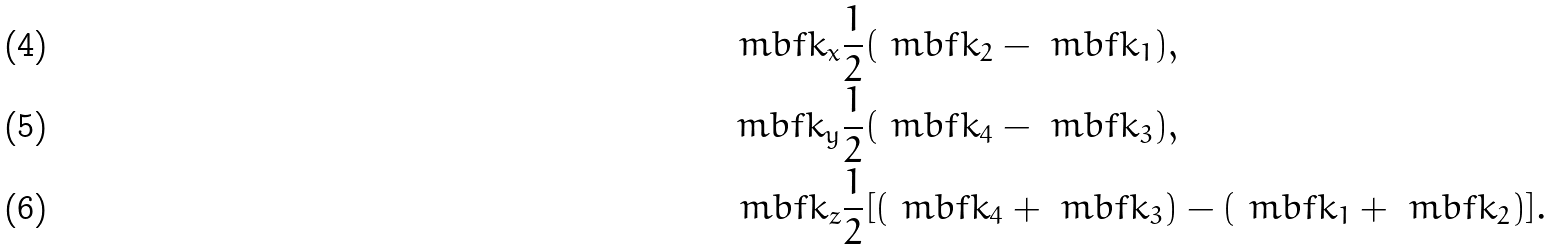Convert formula to latex. <formula><loc_0><loc_0><loc_500><loc_500>\ m b f { k } _ { x } & \frac { 1 } { 2 } ( \ m b f { k } _ { 2 } - \ m b f { k } _ { 1 } ) , \\ \ m b f { k } _ { y } & \frac { 1 } { 2 } ( \ m b f { k } _ { 4 } - \ m b f { k } _ { 3 } ) , \\ \ m b f { k } _ { z } & \frac { 1 } { 2 } [ ( \ m b f { k } _ { 4 } + \ m b f { k } _ { 3 } ) - ( \ m b f { k } _ { 1 } + \ m b f { k } _ { 2 } ) ] .</formula> 